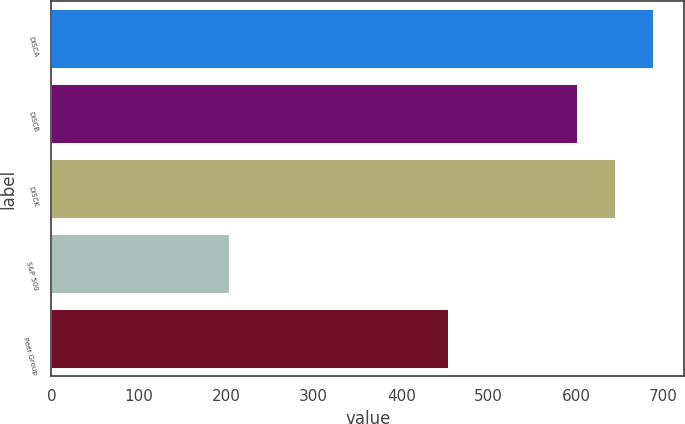<chart> <loc_0><loc_0><loc_500><loc_500><bar_chart><fcel>DISCA<fcel>DISCB<fcel>DISCK<fcel>S&P 500<fcel>Peer Group<nl><fcel>688.86<fcel>602.08<fcel>645.47<fcel>204.63<fcel>454.87<nl></chart> 